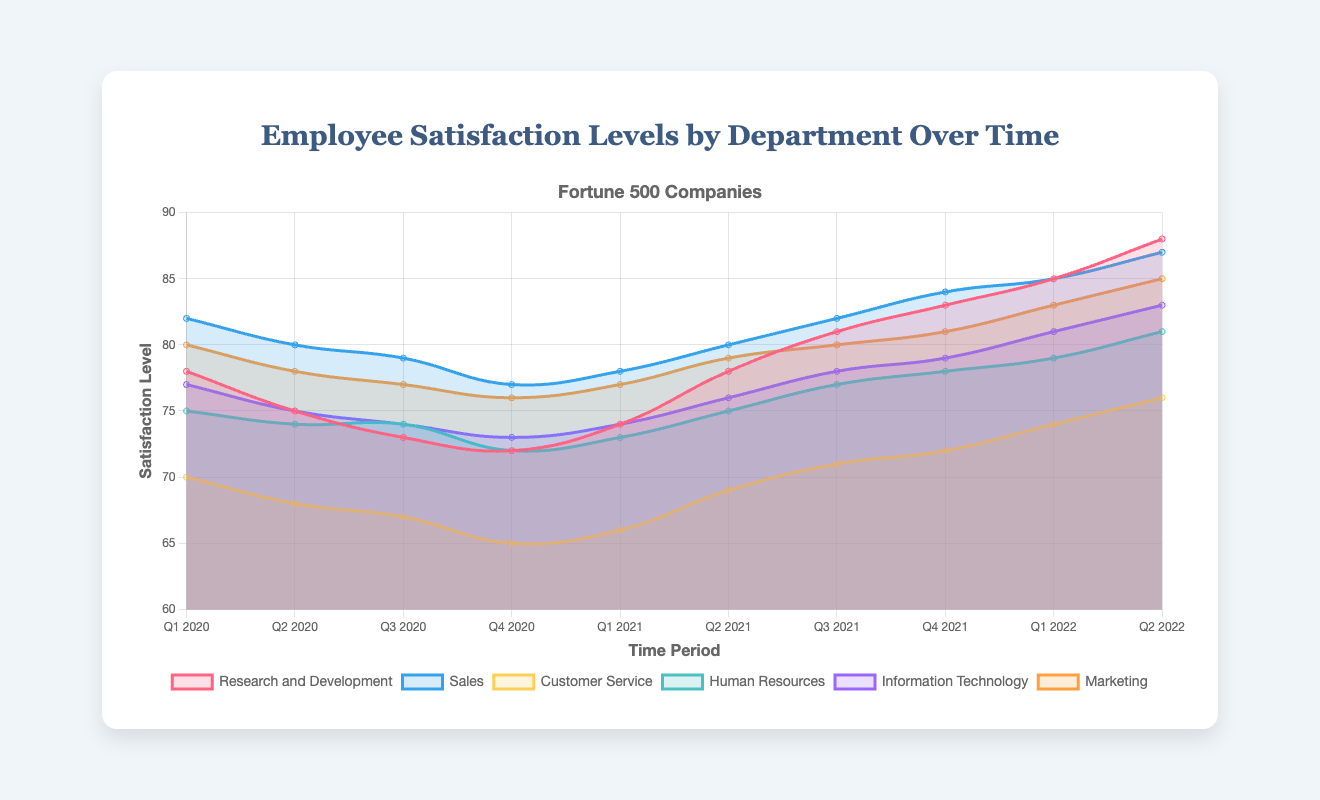Which department has the highest employee satisfaction level in Q2 2022? Compare the satisfaction levels of all departments in Q2 2022. The highest value is in Research and Development with 88.
Answer: Research and Development What is the range of employee satisfaction levels in Customer Service during 2020? Identify the highest and lowest satisfaction levels for Customer Service in 2020. The highest is 70 in Q1, and the lowest is 65 in Q4. The range is 70 - 65.
Answer: 5 Which department showed the most improvement in employee satisfaction from Q1 2020 to Q2 2022? Calculate the difference in satisfaction levels from Q1 2020 to Q2 2022 for all departments. Research and Development shows the largest increase from 78 to 88.
Answer: Research and Development How did the satisfaction levels in Information Technology change from Q1 2021 to Q2 2021? Compare the satisfaction levels in Information Technology between Q1 2021 (74) and Q2 2021 (76). The satisfaction increased by 2 points.
Answer: Increased by 2 Which two departments had the closest satisfaction levels in Q4 2021? Compare the satisfaction levels across departments in Q4 2021. Sales and Information Technology both had a satisfaction level of 79.
Answer: Sales and Information Technology Between Human Resources and Marketing, which had a higher satisfaction level in Q3 2020? Compare the satisfaction levels in Q3 2020. Human Resources had 74 while Marketing had 77. Marketing is higher.
Answer: Marketing What trend can be seen in the satisfaction levels of Sales over the time periods? Observe the pattern of satisfaction levels in Sales. They generally increase over time from 82 to 87 with minor fluctuations.
Answer: Increasing trend If one were to average the satisfaction levels of Research and Development in the first and last quarter shown, what would it be? Calculate the average of satisfaction levels in Q1 2020 (78) and Q2 2022 (88) for Research and Development. (78+88)/2 = 83
Answer: 83 